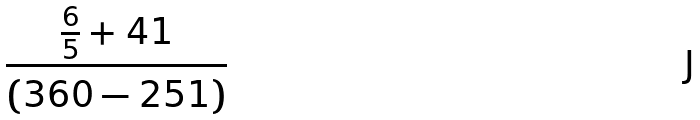<formula> <loc_0><loc_0><loc_500><loc_500>\frac { \frac { 6 } { 5 } + 4 1 } { ( 3 6 0 - 2 5 1 ) }</formula> 